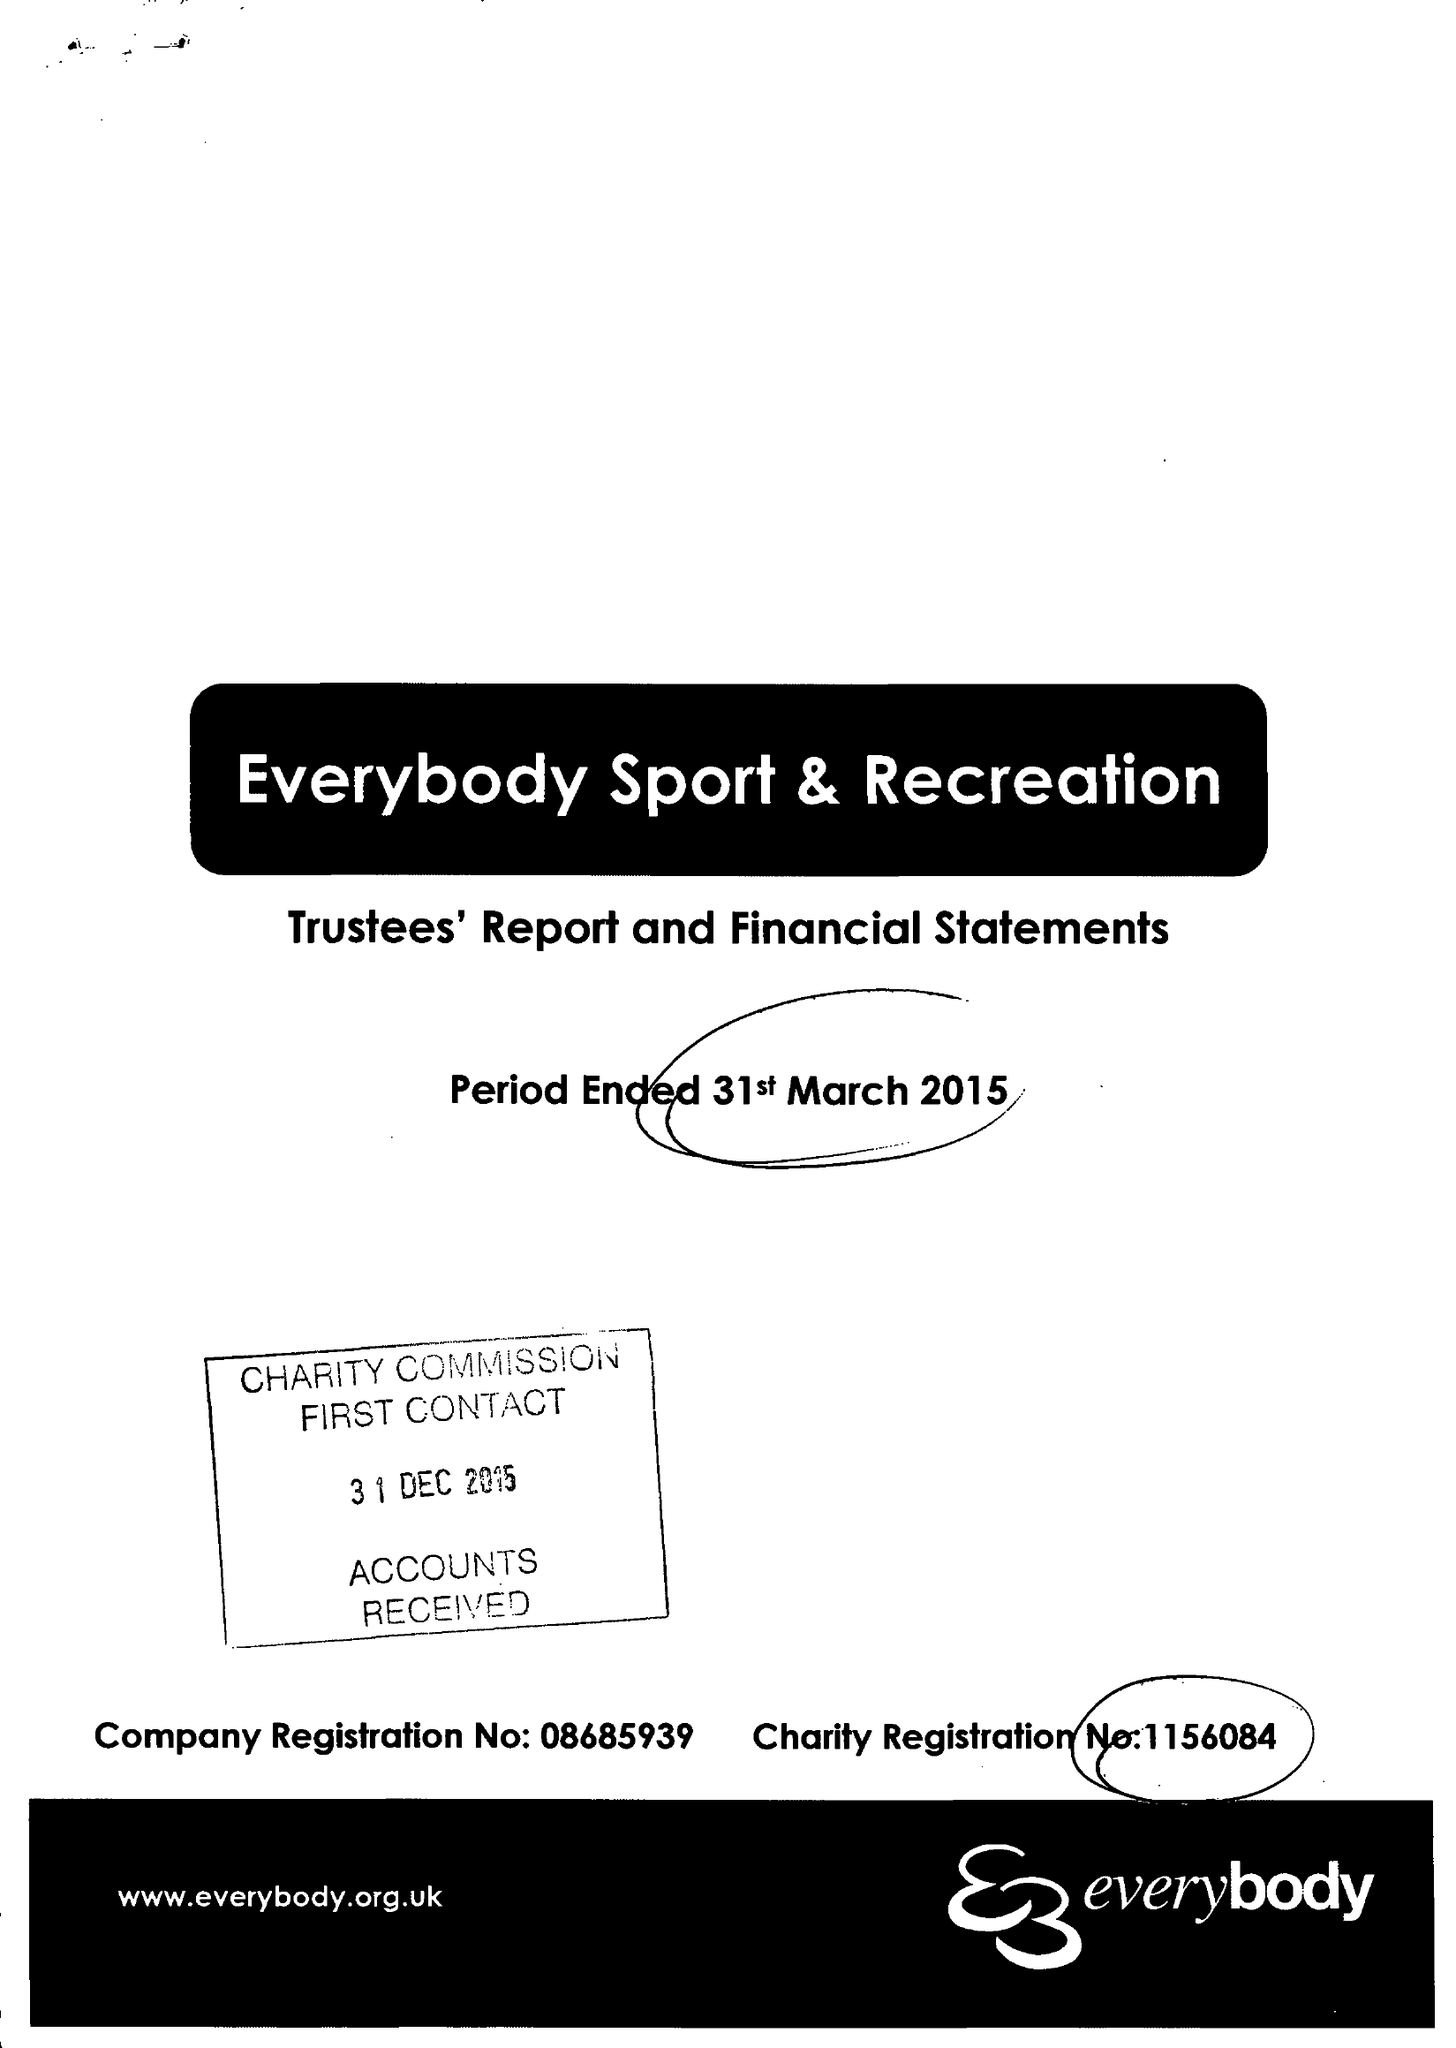What is the value for the spending_annually_in_british_pounds?
Answer the question using a single word or phrase. 12722155.00 